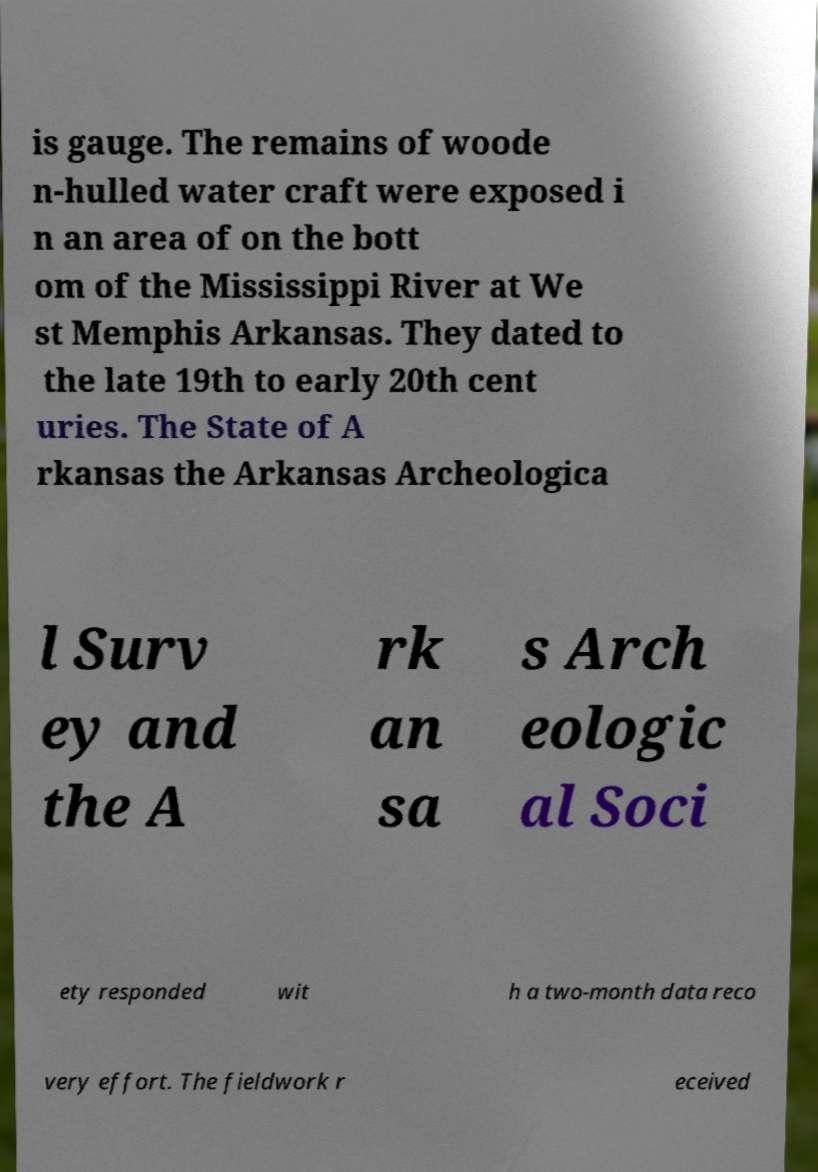What messages or text are displayed in this image? I need them in a readable, typed format. is gauge. The remains of woode n-hulled water craft were exposed i n an area of on the bott om of the Mississippi River at We st Memphis Arkansas. They dated to the late 19th to early 20th cent uries. The State of A rkansas the Arkansas Archeologica l Surv ey and the A rk an sa s Arch eologic al Soci ety responded wit h a two-month data reco very effort. The fieldwork r eceived 